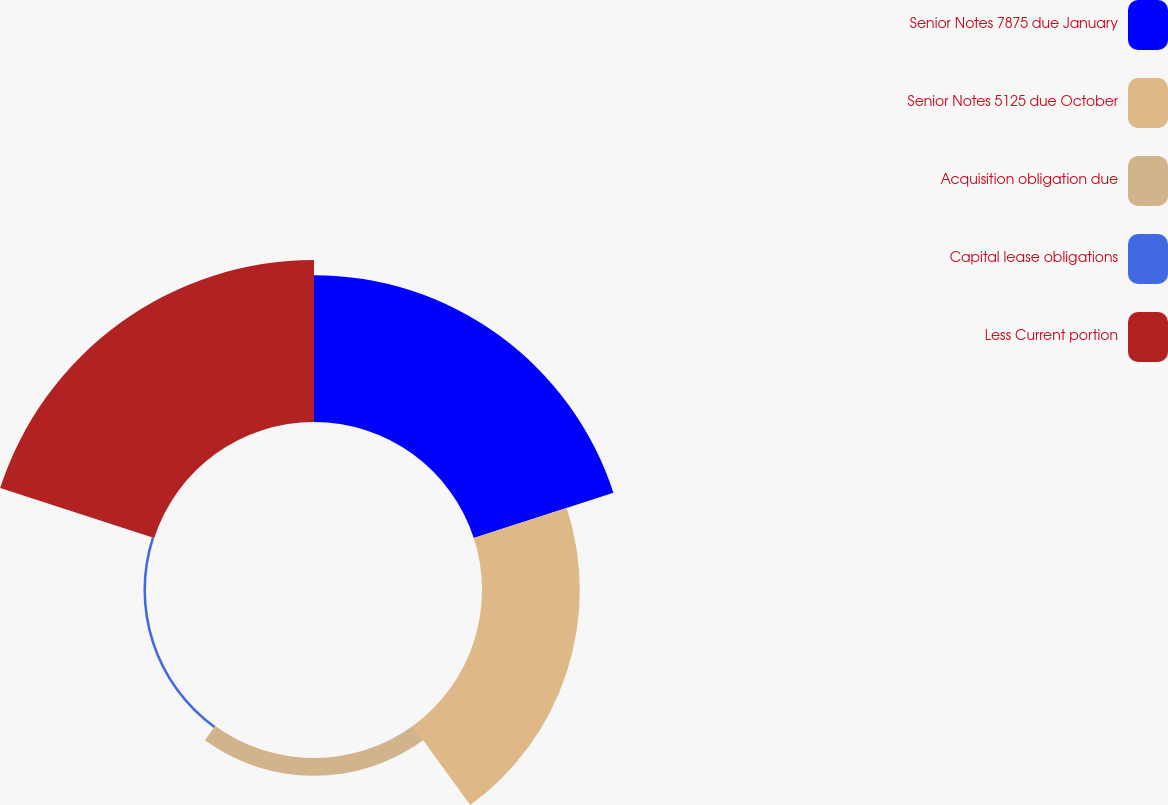Convert chart to OTSL. <chart><loc_0><loc_0><loc_500><loc_500><pie_chart><fcel>Senior Notes 7875 due January<fcel>Senior Notes 5125 due October<fcel>Acquisition obligation due<fcel>Capital lease obligations<fcel>Less Current portion<nl><fcel>34.39%<fcel>22.9%<fcel>4.16%<fcel>0.6%<fcel>37.95%<nl></chart> 